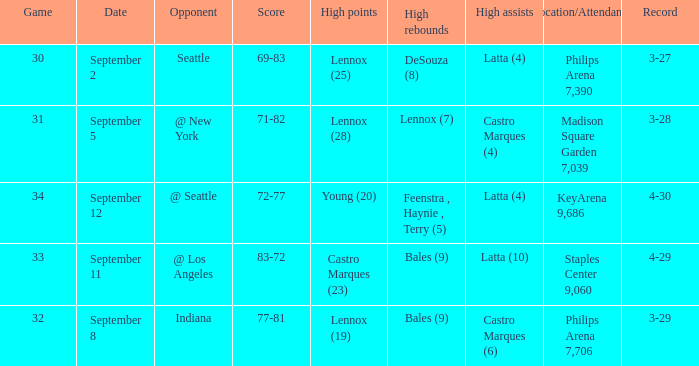When did indiana play? September 8. 